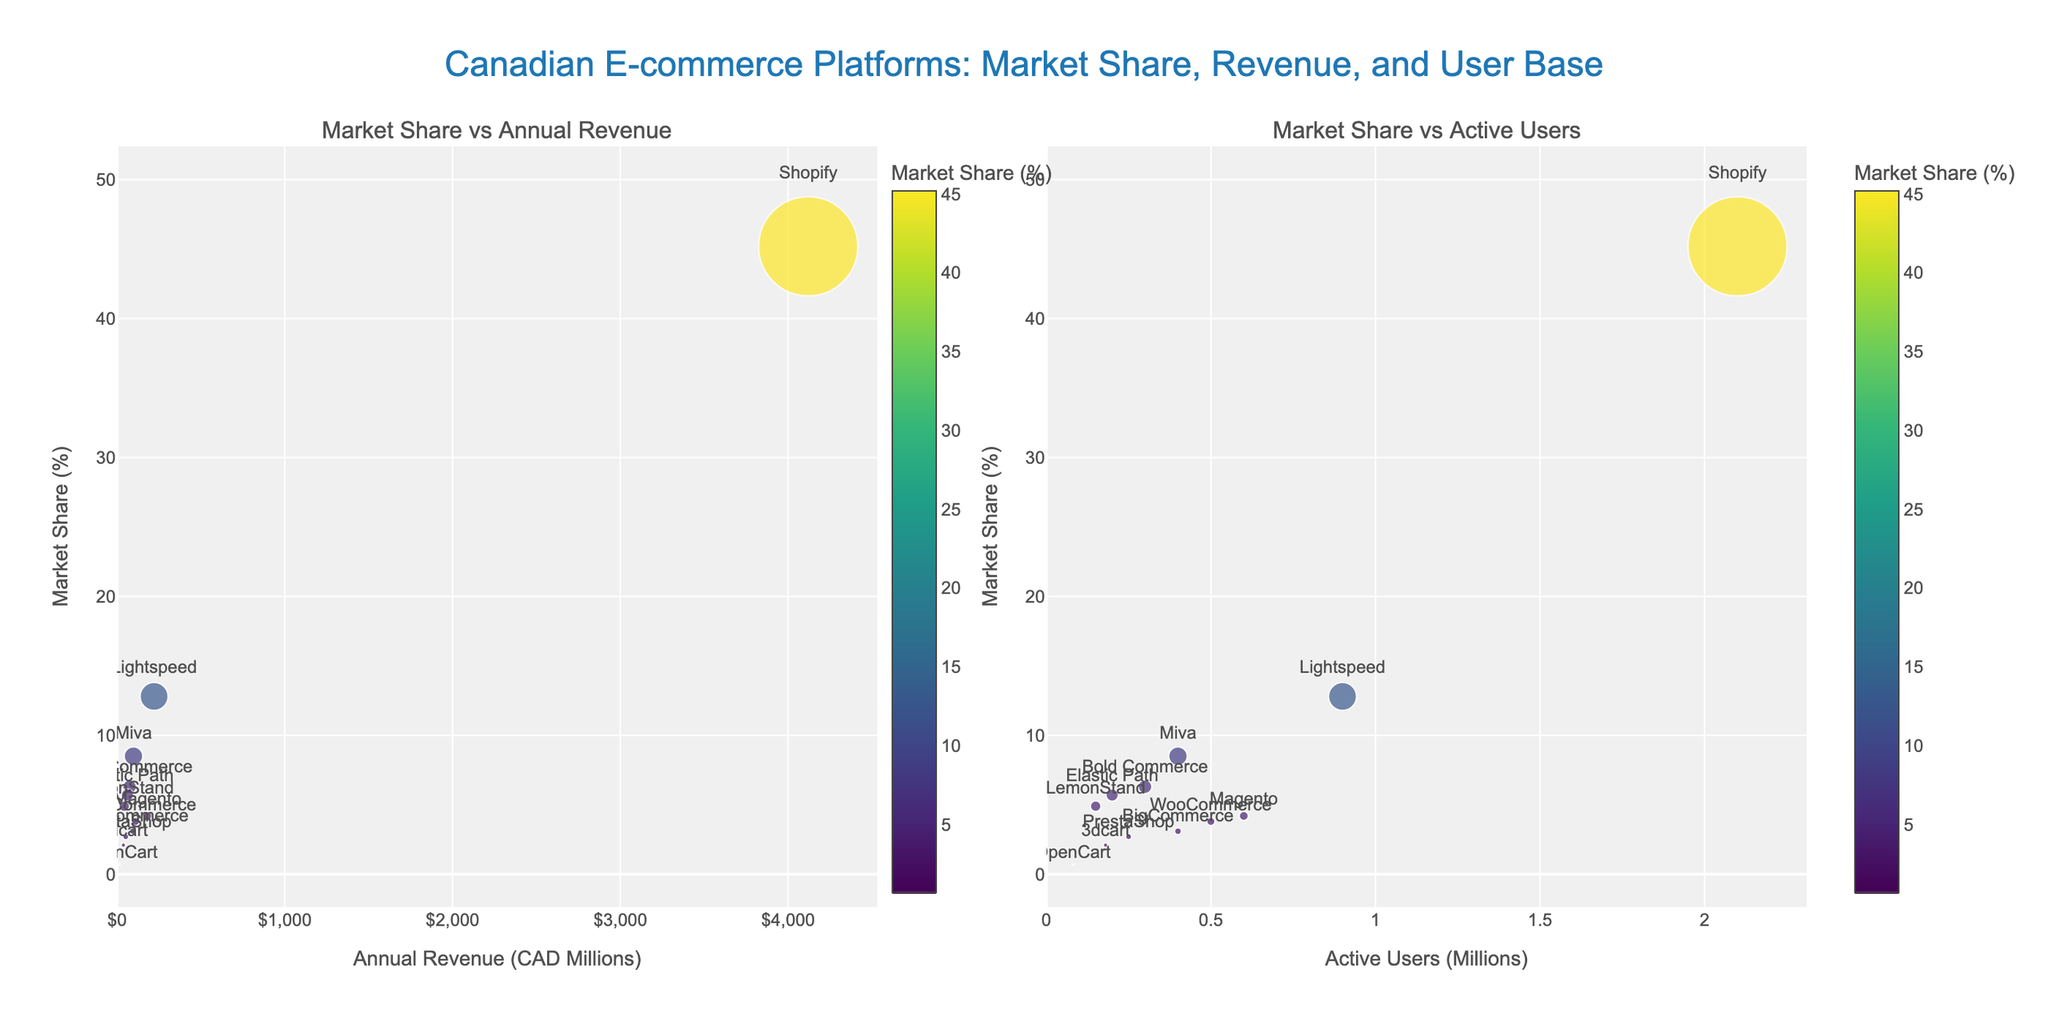What is the title of the figure? The title is located at the top of the figure and is centered. It should provide a summary of what the figure is illustrating.
Answer: Canadian E-commerce Platforms: Market Share, Revenue, and User Base How many platforms are shown in the scatter plots? To determine the number of platforms, count the distinct data points marked by labels in either of the subplots.
Answer: 12 Which platform has the highest market share? Look at the y-axis on either subplot and identify the platform at the highest y-coordinate, which indicates the largest market share value.
Answer: Shopify What is the active user base of the platform with 6.3% market share? Identify the platform with 6.3% market share from the y-axis on the second subplot. Then, check its x-coordinate to find the number of active users.
Answer: 0.3 million Which platform has higher annual revenue: Lightspeed or Magento? Compare the x-coordinates for Lightspeed and Magento on the first subplot. Determine which x-coordinate represents a higher annual revenue.
Answer: Lightspeed Which platform has a larger user base: BigCommerce or 3dcart? Compare the x-coordinates for BigCommerce and 3dcart on the second subplot. The further right x-coordinate will correspond to the larger user base.
Answer: BigCommerce How does the market share of WooCommerce compare to PrestaShop? Locate WooCommerce and PrestaShop on either subplot. Compare their y-coordinates to determine which has a higher market share.
Answer: WooCommerce has a higher market share What is the combined market share of platforms with less than 3 million active users? Identify all platforms on the second subplot with x-coordinates less than 3 and sum their market shares from the y-coordinates.
Answer: 91.6% Which platform has the smallest bubble size, indicating the smallest market share? Identify the smallest bubble in either of the subplots. The platform corresponding to this bubble will have the smallest market share.
Answer: OpenCart 